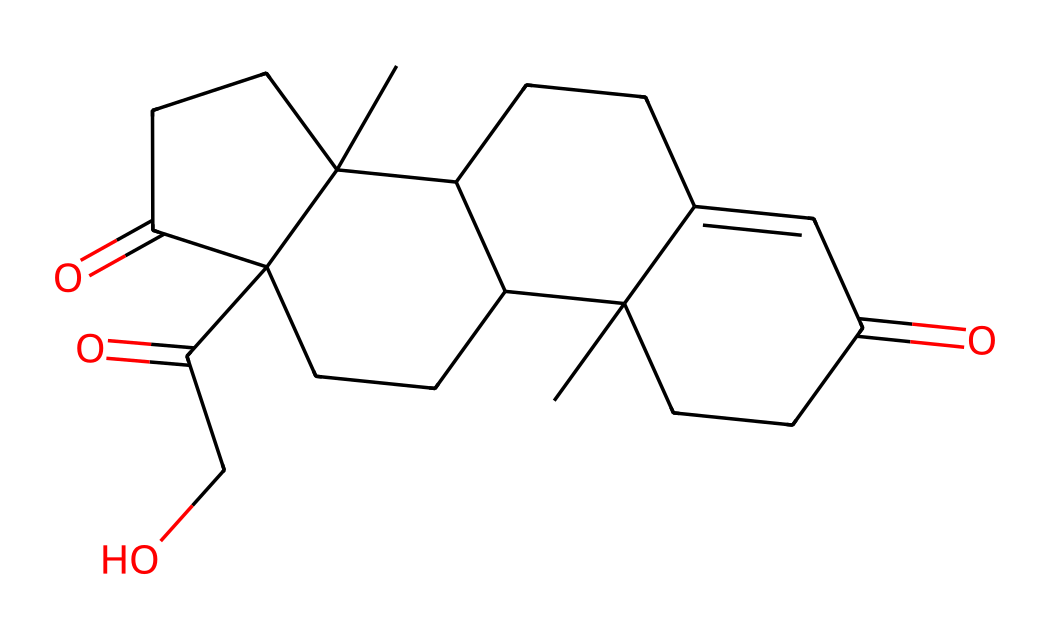What is the molecular formula of cortisone? To find the molecular formula, you count the number of each type of atom within the SMILES representation. The SMILES shows a structure with 21 carbon atoms, 30 hydrogen atoms, and 5 oxygen atoms. Therefore, the molecular formula can be expressed as C21H30O5.
Answer: C21H30O5 How many rings are present in the cortisone structure? By analyzing the SMILES representation, you can identify the connected cyclical parts. There are four distinct ring structures indicated in the SMILES (the numbers 1, 2, 3, and 4 denote connectivity in the rings). So, there are four rings in the cortisone molecule.
Answer: 4 What type of functional groups are present in cortisone? In the SMILES, we can observe the presence of ketone (indicated by the carbonyl C=O) and hydroxyl (−OH) functional groups. The presence of these groups can deduce that cortisone is a steroidal compound with specific functional characteristics.
Answer: ketone, hydroxyl What does the presence of carbonyl groups imply about cortisone? The carbonyl groups (C=O) within the structure indicate that cortisone has the capability to be polar, affecting its solubility characteristics in biological systems. These polar attributes are essential for its activity as an anti-inflammatory medicine.
Answer: polarity How does cortisone's structure relate to its anti-inflammatory properties? Cortisone’s structure features several functional groups, including the hydroxyl and carbonyl groups, and a steroid backbone. This configuration allows cortisone to interact effectively with specific receptors in the body to modulate inflammatory responses, which contributes to its medicinal properties.
Answer: steroid backbone and functional groups What is the significance of the hydroxyl group in cortisone? The hydroxyl group (-OH) is a crucial part of cortisone as it plays a significant role in forming hydrogen bonds, which can influence the solubility and bioavailability of the compound. This may enhance the compound's ability to act on target cells.
Answer: hydrogen bonding How many hydrogen atoms are attached to cortisone's structure? By interpreting the SMILES representation and considering that each carbon typically forms four bonds, closely analyzing the saturation and structural details, you can determine that there are 30 hydrogen atoms in the cortisone structure.
Answer: 30 